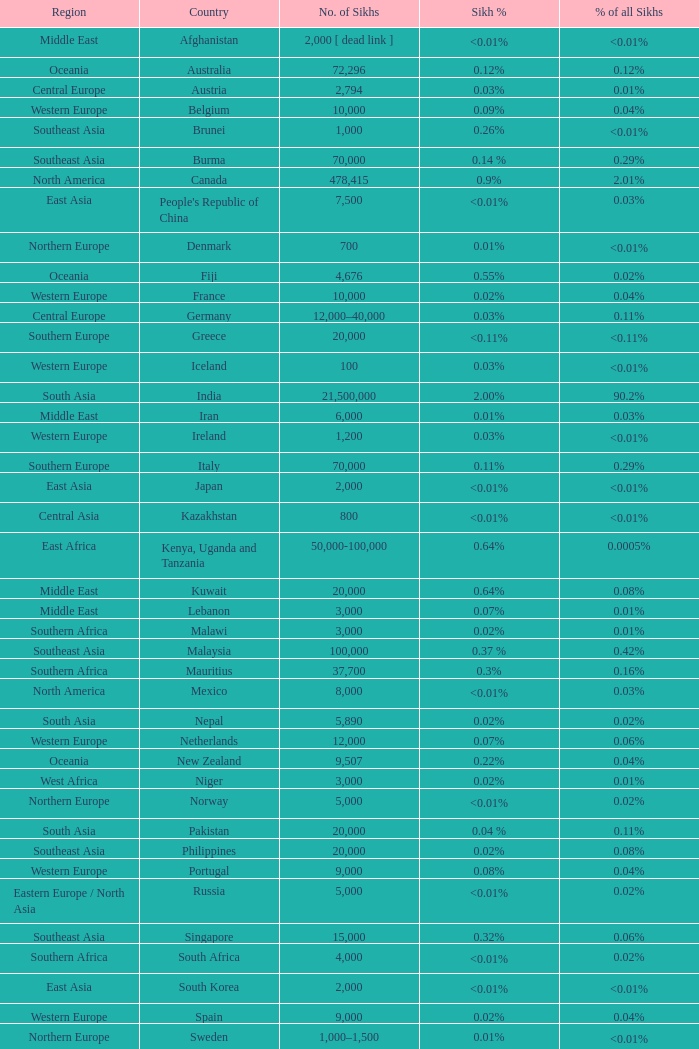What is the number of sikhs in Japan? 2000.0. 